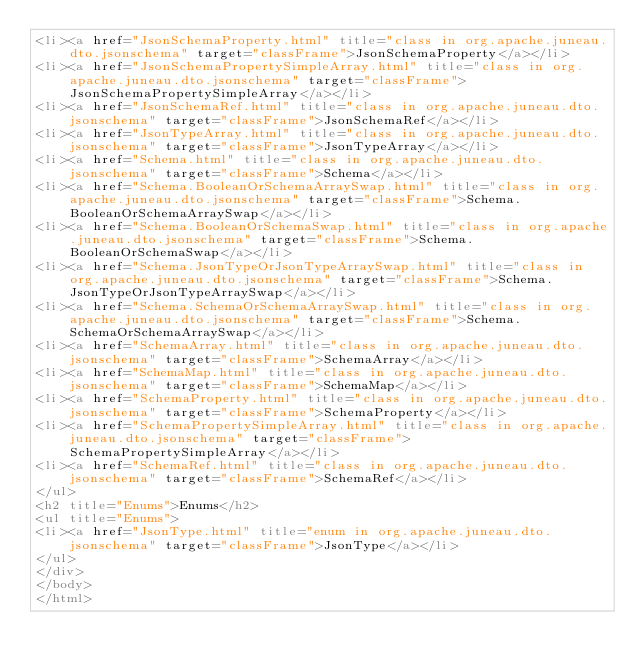Convert code to text. <code><loc_0><loc_0><loc_500><loc_500><_HTML_><li><a href="JsonSchemaProperty.html" title="class in org.apache.juneau.dto.jsonschema" target="classFrame">JsonSchemaProperty</a></li>
<li><a href="JsonSchemaPropertySimpleArray.html" title="class in org.apache.juneau.dto.jsonschema" target="classFrame">JsonSchemaPropertySimpleArray</a></li>
<li><a href="JsonSchemaRef.html" title="class in org.apache.juneau.dto.jsonschema" target="classFrame">JsonSchemaRef</a></li>
<li><a href="JsonTypeArray.html" title="class in org.apache.juneau.dto.jsonschema" target="classFrame">JsonTypeArray</a></li>
<li><a href="Schema.html" title="class in org.apache.juneau.dto.jsonschema" target="classFrame">Schema</a></li>
<li><a href="Schema.BooleanOrSchemaArraySwap.html" title="class in org.apache.juneau.dto.jsonschema" target="classFrame">Schema.BooleanOrSchemaArraySwap</a></li>
<li><a href="Schema.BooleanOrSchemaSwap.html" title="class in org.apache.juneau.dto.jsonschema" target="classFrame">Schema.BooleanOrSchemaSwap</a></li>
<li><a href="Schema.JsonTypeOrJsonTypeArraySwap.html" title="class in org.apache.juneau.dto.jsonschema" target="classFrame">Schema.JsonTypeOrJsonTypeArraySwap</a></li>
<li><a href="Schema.SchemaOrSchemaArraySwap.html" title="class in org.apache.juneau.dto.jsonschema" target="classFrame">Schema.SchemaOrSchemaArraySwap</a></li>
<li><a href="SchemaArray.html" title="class in org.apache.juneau.dto.jsonschema" target="classFrame">SchemaArray</a></li>
<li><a href="SchemaMap.html" title="class in org.apache.juneau.dto.jsonschema" target="classFrame">SchemaMap</a></li>
<li><a href="SchemaProperty.html" title="class in org.apache.juneau.dto.jsonschema" target="classFrame">SchemaProperty</a></li>
<li><a href="SchemaPropertySimpleArray.html" title="class in org.apache.juneau.dto.jsonschema" target="classFrame">SchemaPropertySimpleArray</a></li>
<li><a href="SchemaRef.html" title="class in org.apache.juneau.dto.jsonschema" target="classFrame">SchemaRef</a></li>
</ul>
<h2 title="Enums">Enums</h2>
<ul title="Enums">
<li><a href="JsonType.html" title="enum in org.apache.juneau.dto.jsonschema" target="classFrame">JsonType</a></li>
</ul>
</div>
</body>
</html>
</code> 